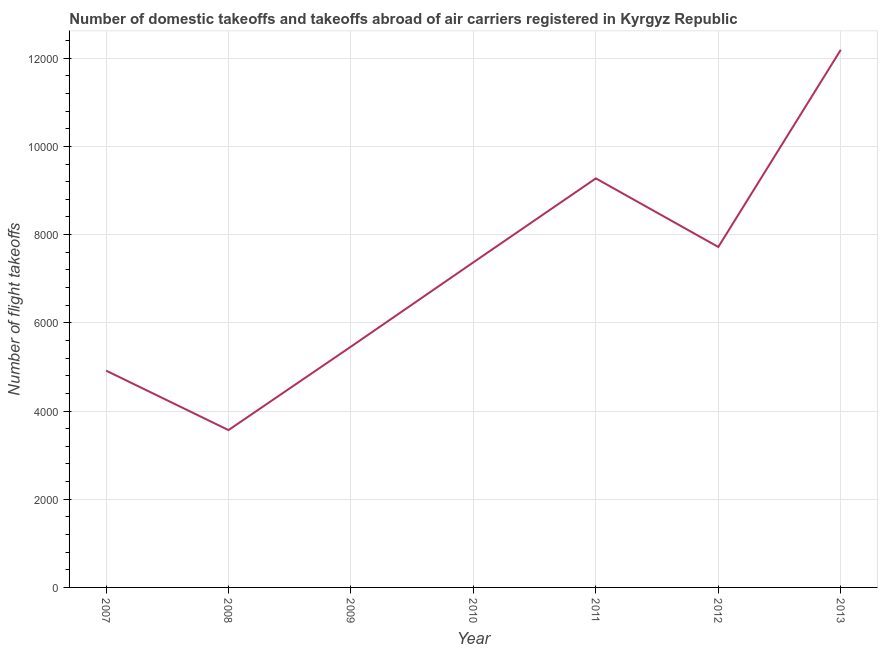What is the number of flight takeoffs in 2008?
Give a very brief answer. 3567. Across all years, what is the maximum number of flight takeoffs?
Offer a very short reply. 1.22e+04. Across all years, what is the minimum number of flight takeoffs?
Your response must be concise. 3567. In which year was the number of flight takeoffs maximum?
Your response must be concise. 2013. In which year was the number of flight takeoffs minimum?
Make the answer very short. 2008. What is the sum of the number of flight takeoffs?
Keep it short and to the point. 5.05e+04. What is the difference between the number of flight takeoffs in 2007 and 2009?
Keep it short and to the point. -543. What is the average number of flight takeoffs per year?
Make the answer very short. 7213.49. What is the median number of flight takeoffs?
Keep it short and to the point. 7371. Do a majority of the years between 2009 and 2010 (inclusive) have number of flight takeoffs greater than 10000 ?
Provide a succinct answer. No. What is the ratio of the number of flight takeoffs in 2009 to that in 2013?
Your answer should be compact. 0.45. Is the number of flight takeoffs in 2008 less than that in 2012?
Give a very brief answer. Yes. Is the difference between the number of flight takeoffs in 2008 and 2012 greater than the difference between any two years?
Keep it short and to the point. No. What is the difference between the highest and the second highest number of flight takeoffs?
Offer a very short reply. 2914.42. What is the difference between the highest and the lowest number of flight takeoffs?
Offer a terse response. 8621.42. How many lines are there?
Your response must be concise. 1. What is the difference between two consecutive major ticks on the Y-axis?
Make the answer very short. 2000. Does the graph contain any zero values?
Give a very brief answer. No. What is the title of the graph?
Offer a terse response. Number of domestic takeoffs and takeoffs abroad of air carriers registered in Kyrgyz Republic. What is the label or title of the Y-axis?
Provide a succinct answer. Number of flight takeoffs. What is the Number of flight takeoffs of 2007?
Offer a terse response. 4916. What is the Number of flight takeoffs of 2008?
Offer a very short reply. 3567. What is the Number of flight takeoffs of 2009?
Make the answer very short. 5459. What is the Number of flight takeoffs of 2010?
Offer a terse response. 7371. What is the Number of flight takeoffs in 2011?
Your response must be concise. 9274. What is the Number of flight takeoffs in 2012?
Make the answer very short. 7719. What is the Number of flight takeoffs in 2013?
Give a very brief answer. 1.22e+04. What is the difference between the Number of flight takeoffs in 2007 and 2008?
Your answer should be compact. 1349. What is the difference between the Number of flight takeoffs in 2007 and 2009?
Provide a succinct answer. -543. What is the difference between the Number of flight takeoffs in 2007 and 2010?
Make the answer very short. -2455. What is the difference between the Number of flight takeoffs in 2007 and 2011?
Offer a terse response. -4358. What is the difference between the Number of flight takeoffs in 2007 and 2012?
Your answer should be very brief. -2803. What is the difference between the Number of flight takeoffs in 2007 and 2013?
Keep it short and to the point. -7272.42. What is the difference between the Number of flight takeoffs in 2008 and 2009?
Ensure brevity in your answer.  -1892. What is the difference between the Number of flight takeoffs in 2008 and 2010?
Your response must be concise. -3804. What is the difference between the Number of flight takeoffs in 2008 and 2011?
Make the answer very short. -5707. What is the difference between the Number of flight takeoffs in 2008 and 2012?
Ensure brevity in your answer.  -4152. What is the difference between the Number of flight takeoffs in 2008 and 2013?
Give a very brief answer. -8621.42. What is the difference between the Number of flight takeoffs in 2009 and 2010?
Ensure brevity in your answer.  -1912. What is the difference between the Number of flight takeoffs in 2009 and 2011?
Give a very brief answer. -3815. What is the difference between the Number of flight takeoffs in 2009 and 2012?
Offer a terse response. -2260. What is the difference between the Number of flight takeoffs in 2009 and 2013?
Provide a succinct answer. -6729.42. What is the difference between the Number of flight takeoffs in 2010 and 2011?
Make the answer very short. -1903. What is the difference between the Number of flight takeoffs in 2010 and 2012?
Give a very brief answer. -348. What is the difference between the Number of flight takeoffs in 2010 and 2013?
Provide a short and direct response. -4817.42. What is the difference between the Number of flight takeoffs in 2011 and 2012?
Provide a short and direct response. 1555. What is the difference between the Number of flight takeoffs in 2011 and 2013?
Your answer should be very brief. -2914.42. What is the difference between the Number of flight takeoffs in 2012 and 2013?
Ensure brevity in your answer.  -4469.42. What is the ratio of the Number of flight takeoffs in 2007 to that in 2008?
Offer a terse response. 1.38. What is the ratio of the Number of flight takeoffs in 2007 to that in 2009?
Your answer should be very brief. 0.9. What is the ratio of the Number of flight takeoffs in 2007 to that in 2010?
Provide a succinct answer. 0.67. What is the ratio of the Number of flight takeoffs in 2007 to that in 2011?
Provide a succinct answer. 0.53. What is the ratio of the Number of flight takeoffs in 2007 to that in 2012?
Keep it short and to the point. 0.64. What is the ratio of the Number of flight takeoffs in 2007 to that in 2013?
Provide a succinct answer. 0.4. What is the ratio of the Number of flight takeoffs in 2008 to that in 2009?
Give a very brief answer. 0.65. What is the ratio of the Number of flight takeoffs in 2008 to that in 2010?
Provide a succinct answer. 0.48. What is the ratio of the Number of flight takeoffs in 2008 to that in 2011?
Keep it short and to the point. 0.39. What is the ratio of the Number of flight takeoffs in 2008 to that in 2012?
Your response must be concise. 0.46. What is the ratio of the Number of flight takeoffs in 2008 to that in 2013?
Offer a very short reply. 0.29. What is the ratio of the Number of flight takeoffs in 2009 to that in 2010?
Ensure brevity in your answer.  0.74. What is the ratio of the Number of flight takeoffs in 2009 to that in 2011?
Give a very brief answer. 0.59. What is the ratio of the Number of flight takeoffs in 2009 to that in 2012?
Your response must be concise. 0.71. What is the ratio of the Number of flight takeoffs in 2009 to that in 2013?
Give a very brief answer. 0.45. What is the ratio of the Number of flight takeoffs in 2010 to that in 2011?
Keep it short and to the point. 0.8. What is the ratio of the Number of flight takeoffs in 2010 to that in 2012?
Provide a short and direct response. 0.95. What is the ratio of the Number of flight takeoffs in 2010 to that in 2013?
Provide a succinct answer. 0.6. What is the ratio of the Number of flight takeoffs in 2011 to that in 2012?
Provide a succinct answer. 1.2. What is the ratio of the Number of flight takeoffs in 2011 to that in 2013?
Ensure brevity in your answer.  0.76. What is the ratio of the Number of flight takeoffs in 2012 to that in 2013?
Make the answer very short. 0.63. 